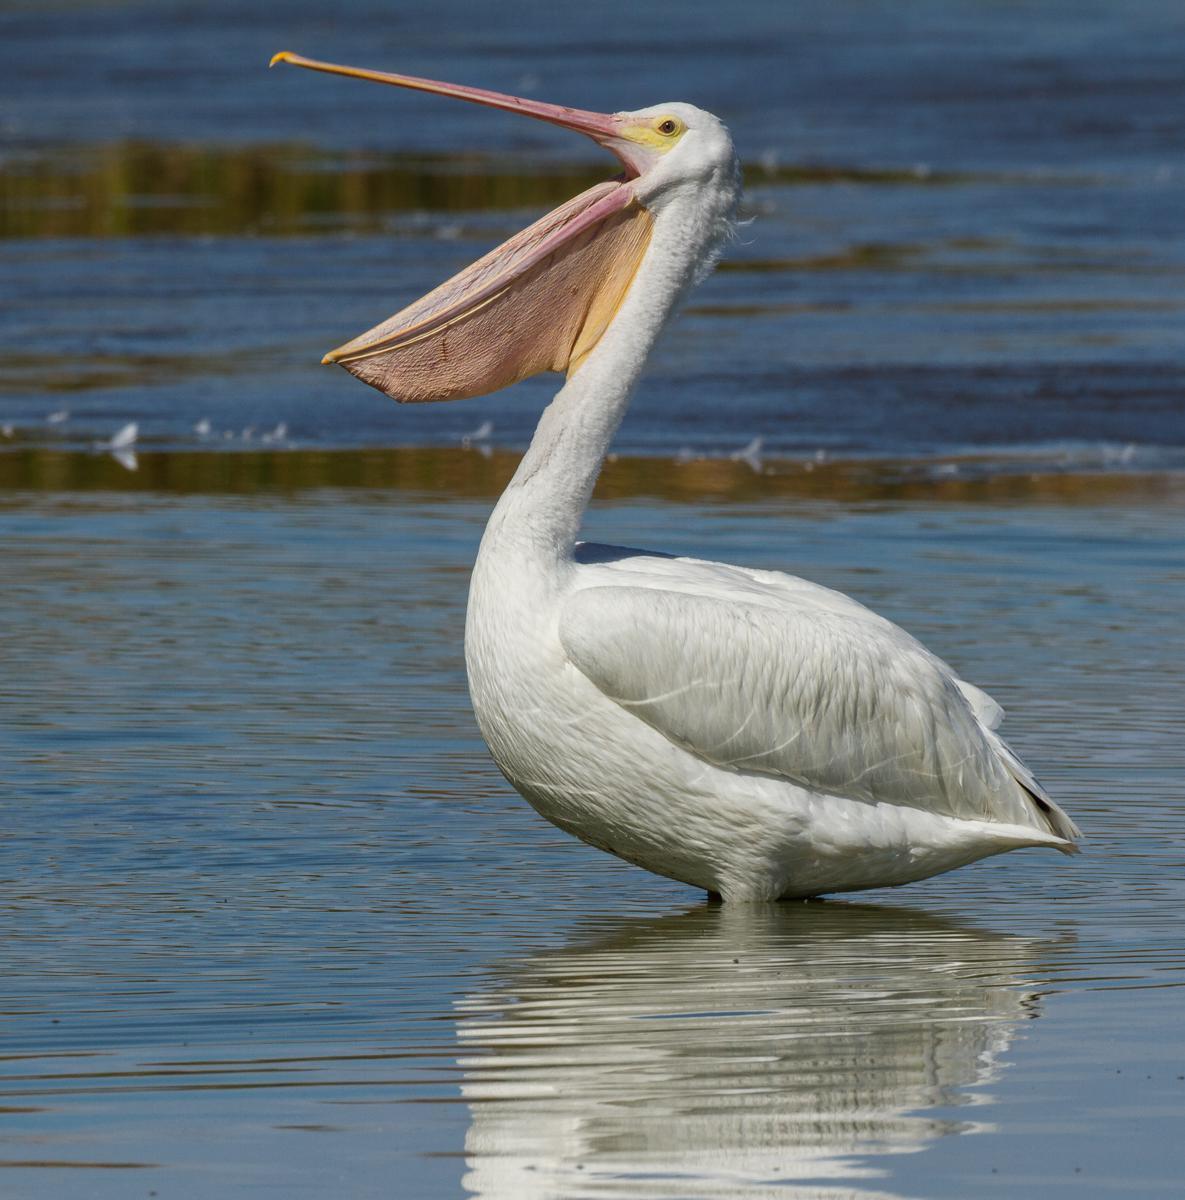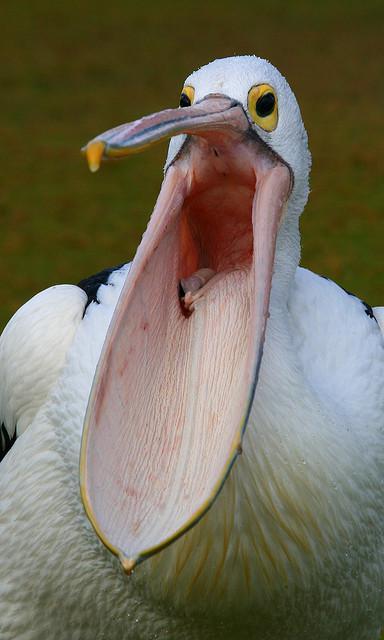The first image is the image on the left, the second image is the image on the right. Evaluate the accuracy of this statement regarding the images: "A fish is in a bird's mouth.". Is it true? Answer yes or no. No. 